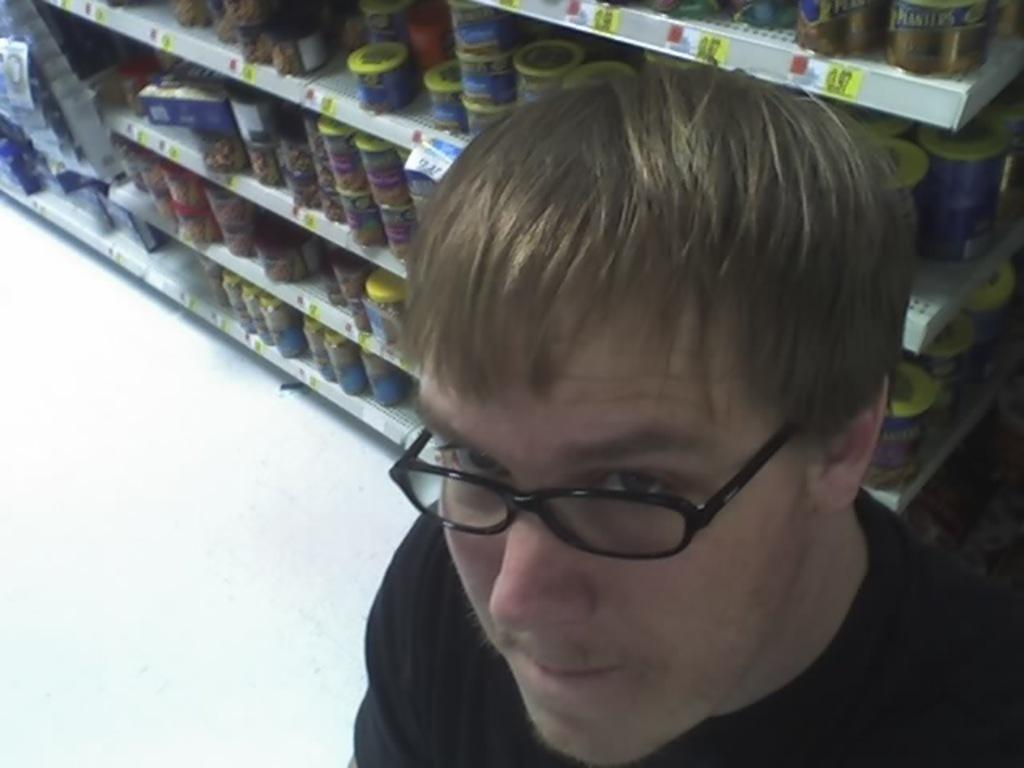What is the person in the image wearing? The person in the image is wearing spectacles. What can be seen in the background of the image? There are racks in the background of the image. What information is provided on the objects in the image? Price tags are present in the image. What type of containers are visible in the racks? There are jars in the racks. What else can be found in the racks besides jars? There are other objects in the racks. Can you see a receipt for the objects in the racks in the image? There is no receipt visible in the image. Is there a hair salon in the image? There is no hair salon or any reference to hair in the image. 